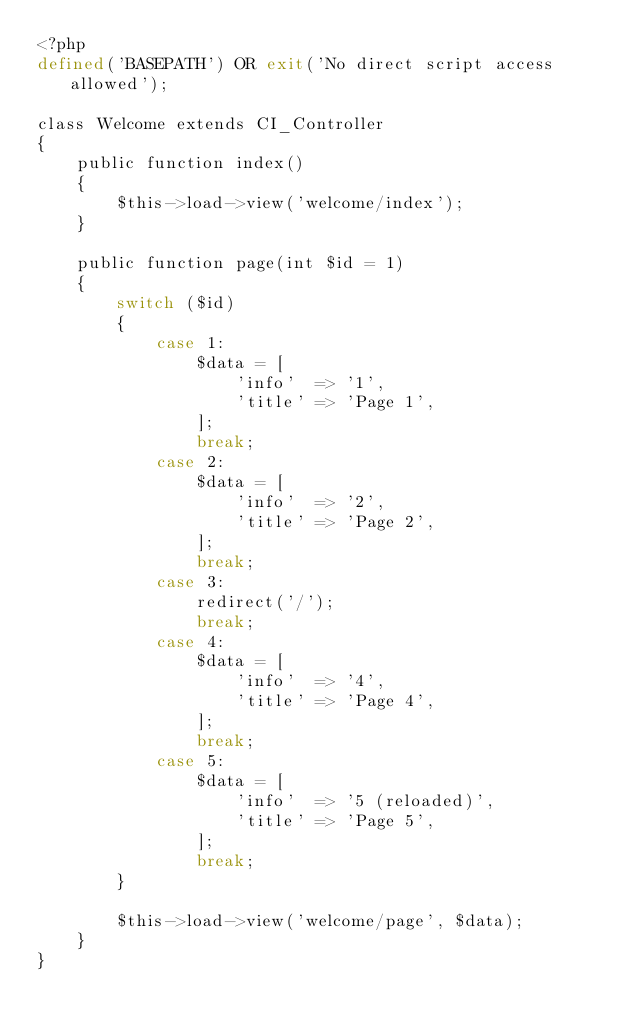Convert code to text. <code><loc_0><loc_0><loc_500><loc_500><_PHP_><?php
defined('BASEPATH') OR exit('No direct script access allowed');

class Welcome extends CI_Controller
{
	public function index()
	{
		$this->load->view('welcome/index');
	}

	public function page(int $id = 1)
	{
		switch ($id)
		{
			case 1:
				$data = [
					'info'  => '1',
					'title' => 'Page 1',
				];
				break;
			case 2:
				$data = [
					'info'  => '2',
					'title' => 'Page 2',
				];
				break;
			case 3:
				redirect('/');
				break;
			case 4:
				$data = [
					'info'  => '4',
					'title' => 'Page 4',
				];
				break;
			case 5:
				$data = [
					'info'  => '5 (reloaded)',
					'title' => 'Page 5',
				];
				break;
		}

		$this->load->view('welcome/page', $data);
	}
}
</code> 